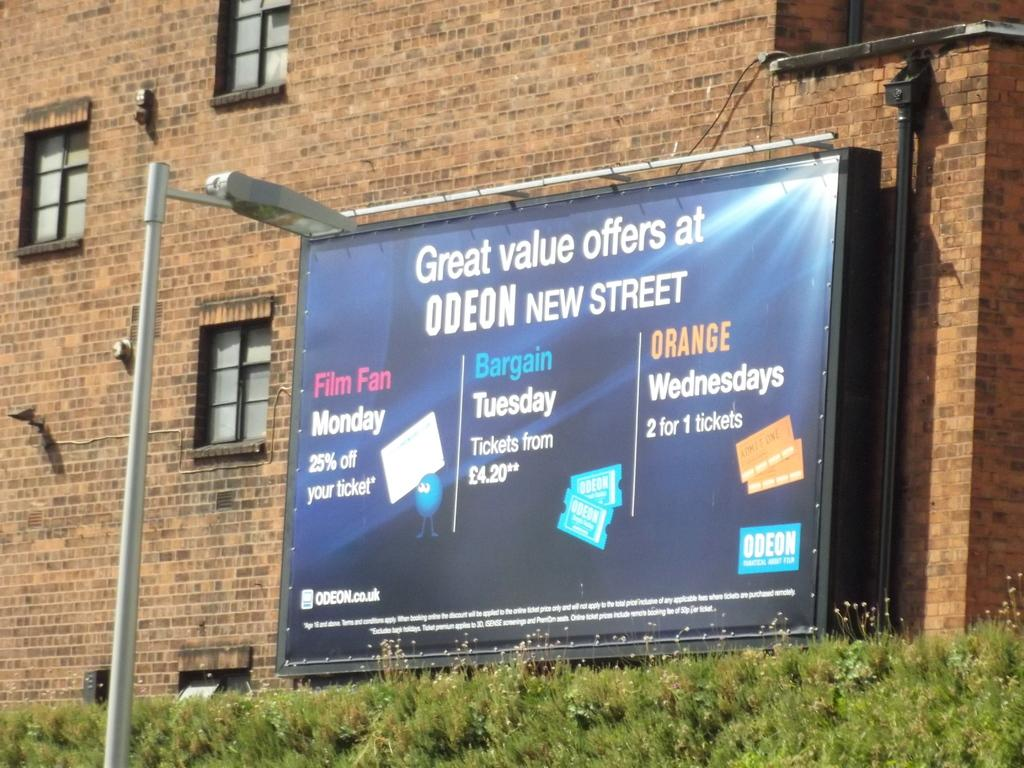<image>
Write a terse but informative summary of the picture. Billboard on a wall which says "Great value offers at ODEON". 